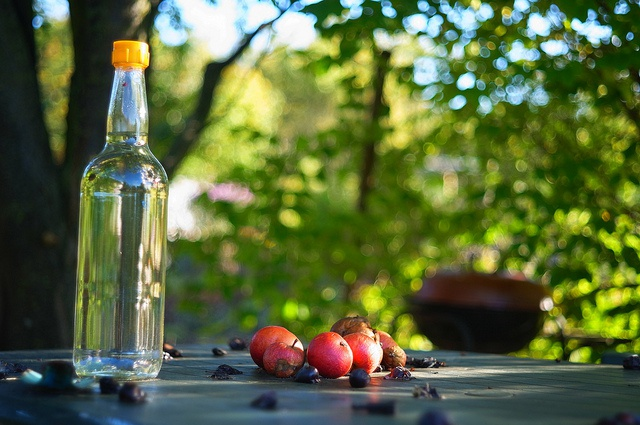Describe the objects in this image and their specific colors. I can see bottle in black, darkgreen, gray, and olive tones, apple in black, brown, maroon, and salmon tones, apple in black, maroon, and brown tones, apple in black, brown, maroon, and red tones, and apple in black, white, red, and salmon tones in this image. 